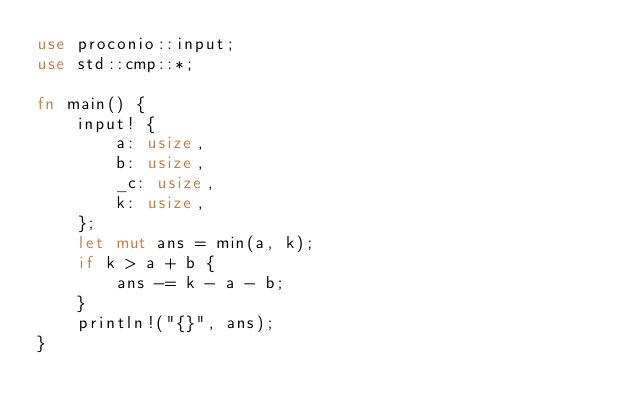Convert code to text. <code><loc_0><loc_0><loc_500><loc_500><_Rust_>use proconio::input;
use std::cmp::*;

fn main() {
    input! {
        a: usize,
        b: usize,
        _c: usize,
        k: usize,
    };
    let mut ans = min(a, k);
    if k > a + b {
        ans -= k - a - b;
    }
    println!("{}", ans);
}
</code> 